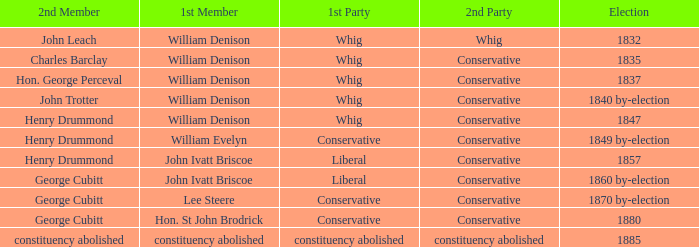Which party's 1st member is William Denison in the election of 1832? Whig. Write the full table. {'header': ['2nd Member', '1st Member', '1st Party', '2nd Party', 'Election'], 'rows': [['John Leach', 'William Denison', 'Whig', 'Whig', '1832'], ['Charles Barclay', 'William Denison', 'Whig', 'Conservative', '1835'], ['Hon. George Perceval', 'William Denison', 'Whig', 'Conservative', '1837'], ['John Trotter', 'William Denison', 'Whig', 'Conservative', '1840 by-election'], ['Henry Drummond', 'William Denison', 'Whig', 'Conservative', '1847'], ['Henry Drummond', 'William Evelyn', 'Conservative', 'Conservative', '1849 by-election'], ['Henry Drummond', 'John Ivatt Briscoe', 'Liberal', 'Conservative', '1857'], ['George Cubitt', 'John Ivatt Briscoe', 'Liberal', 'Conservative', '1860 by-election'], ['George Cubitt', 'Lee Steere', 'Conservative', 'Conservative', '1870 by-election'], ['George Cubitt', 'Hon. St John Brodrick', 'Conservative', 'Conservative', '1880'], ['constituency abolished', 'constituency abolished', 'constituency abolished', 'constituency abolished', '1885']]} 